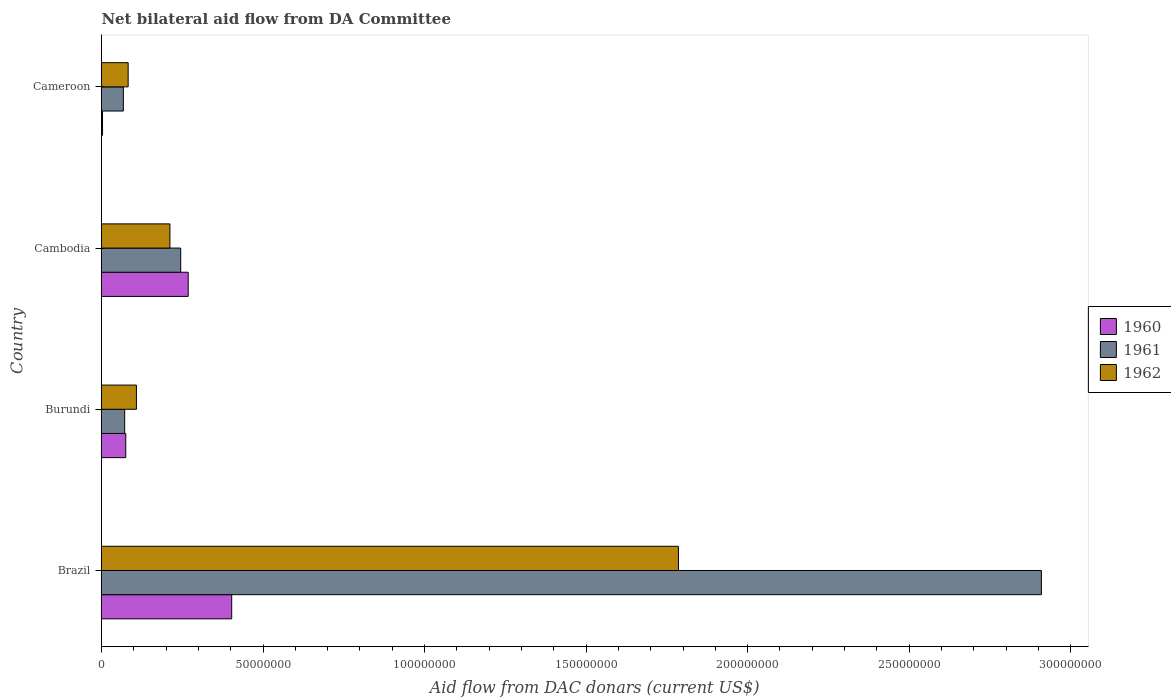Are the number of bars per tick equal to the number of legend labels?
Your response must be concise. Yes. How many bars are there on the 1st tick from the top?
Your answer should be compact. 3. What is the label of the 3rd group of bars from the top?
Your answer should be compact. Burundi. What is the aid flow in in 1960 in Burundi?
Ensure brevity in your answer.  7.51e+06. Across all countries, what is the maximum aid flow in in 1962?
Keep it short and to the point. 1.79e+08. Across all countries, what is the minimum aid flow in in 1962?
Provide a short and direct response. 8.25e+06. In which country was the aid flow in in 1960 minimum?
Provide a short and direct response. Cameroon. What is the total aid flow in in 1962 in the graph?
Provide a succinct answer. 2.19e+08. What is the difference between the aid flow in in 1962 in Burundi and that in Cambodia?
Keep it short and to the point. -1.04e+07. What is the difference between the aid flow in in 1962 in Cameroon and the aid flow in in 1960 in Brazil?
Your answer should be compact. -3.20e+07. What is the average aid flow in in 1962 per country?
Ensure brevity in your answer.  5.47e+07. What is the difference between the aid flow in in 1962 and aid flow in in 1960 in Cambodia?
Offer a very short reply. -5.65e+06. What is the ratio of the aid flow in in 1960 in Burundi to that in Cameroon?
Your response must be concise. 23.47. What is the difference between the highest and the second highest aid flow in in 1961?
Provide a succinct answer. 2.66e+08. What is the difference between the highest and the lowest aid flow in in 1962?
Provide a short and direct response. 1.70e+08. In how many countries, is the aid flow in in 1960 greater than the average aid flow in in 1960 taken over all countries?
Offer a very short reply. 2. What does the 3rd bar from the bottom in Cameroon represents?
Offer a very short reply. 1962. Is it the case that in every country, the sum of the aid flow in in 1961 and aid flow in in 1960 is greater than the aid flow in in 1962?
Make the answer very short. No. How many countries are there in the graph?
Offer a very short reply. 4. What is the difference between two consecutive major ticks on the X-axis?
Ensure brevity in your answer.  5.00e+07. Where does the legend appear in the graph?
Offer a terse response. Center right. What is the title of the graph?
Provide a short and direct response. Net bilateral aid flow from DA Committee. What is the label or title of the X-axis?
Offer a terse response. Aid flow from DAC donars (current US$). What is the label or title of the Y-axis?
Offer a very short reply. Country. What is the Aid flow from DAC donars (current US$) in 1960 in Brazil?
Your answer should be compact. 4.03e+07. What is the Aid flow from DAC donars (current US$) in 1961 in Brazil?
Your response must be concise. 2.91e+08. What is the Aid flow from DAC donars (current US$) in 1962 in Brazil?
Your answer should be compact. 1.79e+08. What is the Aid flow from DAC donars (current US$) of 1960 in Burundi?
Provide a succinct answer. 7.51e+06. What is the Aid flow from DAC donars (current US$) in 1961 in Burundi?
Provide a succinct answer. 7.17e+06. What is the Aid flow from DAC donars (current US$) in 1962 in Burundi?
Keep it short and to the point. 1.08e+07. What is the Aid flow from DAC donars (current US$) in 1960 in Cambodia?
Provide a succinct answer. 2.68e+07. What is the Aid flow from DAC donars (current US$) of 1961 in Cambodia?
Provide a succinct answer. 2.45e+07. What is the Aid flow from DAC donars (current US$) in 1962 in Cambodia?
Give a very brief answer. 2.12e+07. What is the Aid flow from DAC donars (current US$) in 1961 in Cameroon?
Keep it short and to the point. 6.76e+06. What is the Aid flow from DAC donars (current US$) in 1962 in Cameroon?
Make the answer very short. 8.25e+06. Across all countries, what is the maximum Aid flow from DAC donars (current US$) in 1960?
Give a very brief answer. 4.03e+07. Across all countries, what is the maximum Aid flow from DAC donars (current US$) of 1961?
Your answer should be very brief. 2.91e+08. Across all countries, what is the maximum Aid flow from DAC donars (current US$) of 1962?
Give a very brief answer. 1.79e+08. Across all countries, what is the minimum Aid flow from DAC donars (current US$) of 1960?
Your answer should be very brief. 3.20e+05. Across all countries, what is the minimum Aid flow from DAC donars (current US$) in 1961?
Make the answer very short. 6.76e+06. Across all countries, what is the minimum Aid flow from DAC donars (current US$) of 1962?
Your answer should be very brief. 8.25e+06. What is the total Aid flow from DAC donars (current US$) in 1960 in the graph?
Keep it short and to the point. 7.50e+07. What is the total Aid flow from DAC donars (current US$) in 1961 in the graph?
Your response must be concise. 3.29e+08. What is the total Aid flow from DAC donars (current US$) in 1962 in the graph?
Provide a succinct answer. 2.19e+08. What is the difference between the Aid flow from DAC donars (current US$) of 1960 in Brazil and that in Burundi?
Provide a succinct answer. 3.28e+07. What is the difference between the Aid flow from DAC donars (current US$) in 1961 in Brazil and that in Burundi?
Provide a succinct answer. 2.84e+08. What is the difference between the Aid flow from DAC donars (current US$) of 1962 in Brazil and that in Burundi?
Your response must be concise. 1.68e+08. What is the difference between the Aid flow from DAC donars (current US$) of 1960 in Brazil and that in Cambodia?
Give a very brief answer. 1.35e+07. What is the difference between the Aid flow from DAC donars (current US$) of 1961 in Brazil and that in Cambodia?
Make the answer very short. 2.66e+08. What is the difference between the Aid flow from DAC donars (current US$) in 1962 in Brazil and that in Cambodia?
Make the answer very short. 1.57e+08. What is the difference between the Aid flow from DAC donars (current US$) of 1960 in Brazil and that in Cameroon?
Your answer should be compact. 4.00e+07. What is the difference between the Aid flow from DAC donars (current US$) of 1961 in Brazil and that in Cameroon?
Your answer should be compact. 2.84e+08. What is the difference between the Aid flow from DAC donars (current US$) of 1962 in Brazil and that in Cameroon?
Give a very brief answer. 1.70e+08. What is the difference between the Aid flow from DAC donars (current US$) in 1960 in Burundi and that in Cambodia?
Your answer should be compact. -1.93e+07. What is the difference between the Aid flow from DAC donars (current US$) of 1961 in Burundi and that in Cambodia?
Provide a short and direct response. -1.74e+07. What is the difference between the Aid flow from DAC donars (current US$) in 1962 in Burundi and that in Cambodia?
Give a very brief answer. -1.04e+07. What is the difference between the Aid flow from DAC donars (current US$) of 1960 in Burundi and that in Cameroon?
Make the answer very short. 7.19e+06. What is the difference between the Aid flow from DAC donars (current US$) of 1962 in Burundi and that in Cameroon?
Provide a succinct answer. 2.56e+06. What is the difference between the Aid flow from DAC donars (current US$) of 1960 in Cambodia and that in Cameroon?
Provide a short and direct response. 2.65e+07. What is the difference between the Aid flow from DAC donars (current US$) in 1961 in Cambodia and that in Cameroon?
Your response must be concise. 1.78e+07. What is the difference between the Aid flow from DAC donars (current US$) in 1962 in Cambodia and that in Cameroon?
Offer a terse response. 1.29e+07. What is the difference between the Aid flow from DAC donars (current US$) of 1960 in Brazil and the Aid flow from DAC donars (current US$) of 1961 in Burundi?
Ensure brevity in your answer.  3.31e+07. What is the difference between the Aid flow from DAC donars (current US$) of 1960 in Brazil and the Aid flow from DAC donars (current US$) of 1962 in Burundi?
Your answer should be very brief. 2.95e+07. What is the difference between the Aid flow from DAC donars (current US$) of 1961 in Brazil and the Aid flow from DAC donars (current US$) of 1962 in Burundi?
Keep it short and to the point. 2.80e+08. What is the difference between the Aid flow from DAC donars (current US$) of 1960 in Brazil and the Aid flow from DAC donars (current US$) of 1961 in Cambodia?
Your response must be concise. 1.58e+07. What is the difference between the Aid flow from DAC donars (current US$) in 1960 in Brazil and the Aid flow from DAC donars (current US$) in 1962 in Cambodia?
Your response must be concise. 1.91e+07. What is the difference between the Aid flow from DAC donars (current US$) in 1961 in Brazil and the Aid flow from DAC donars (current US$) in 1962 in Cambodia?
Offer a very short reply. 2.70e+08. What is the difference between the Aid flow from DAC donars (current US$) of 1960 in Brazil and the Aid flow from DAC donars (current US$) of 1961 in Cameroon?
Make the answer very short. 3.35e+07. What is the difference between the Aid flow from DAC donars (current US$) of 1960 in Brazil and the Aid flow from DAC donars (current US$) of 1962 in Cameroon?
Offer a very short reply. 3.20e+07. What is the difference between the Aid flow from DAC donars (current US$) in 1961 in Brazil and the Aid flow from DAC donars (current US$) in 1962 in Cameroon?
Give a very brief answer. 2.83e+08. What is the difference between the Aid flow from DAC donars (current US$) of 1960 in Burundi and the Aid flow from DAC donars (current US$) of 1961 in Cambodia?
Make the answer very short. -1.70e+07. What is the difference between the Aid flow from DAC donars (current US$) of 1960 in Burundi and the Aid flow from DAC donars (current US$) of 1962 in Cambodia?
Your response must be concise. -1.37e+07. What is the difference between the Aid flow from DAC donars (current US$) in 1961 in Burundi and the Aid flow from DAC donars (current US$) in 1962 in Cambodia?
Make the answer very short. -1.40e+07. What is the difference between the Aid flow from DAC donars (current US$) in 1960 in Burundi and the Aid flow from DAC donars (current US$) in 1961 in Cameroon?
Offer a terse response. 7.50e+05. What is the difference between the Aid flow from DAC donars (current US$) in 1960 in Burundi and the Aid flow from DAC donars (current US$) in 1962 in Cameroon?
Your answer should be compact. -7.40e+05. What is the difference between the Aid flow from DAC donars (current US$) in 1961 in Burundi and the Aid flow from DAC donars (current US$) in 1962 in Cameroon?
Make the answer very short. -1.08e+06. What is the difference between the Aid flow from DAC donars (current US$) of 1960 in Cambodia and the Aid flow from DAC donars (current US$) of 1961 in Cameroon?
Your answer should be compact. 2.01e+07. What is the difference between the Aid flow from DAC donars (current US$) in 1960 in Cambodia and the Aid flow from DAC donars (current US$) in 1962 in Cameroon?
Offer a terse response. 1.86e+07. What is the difference between the Aid flow from DAC donars (current US$) in 1961 in Cambodia and the Aid flow from DAC donars (current US$) in 1962 in Cameroon?
Provide a short and direct response. 1.63e+07. What is the average Aid flow from DAC donars (current US$) of 1960 per country?
Keep it short and to the point. 1.87e+07. What is the average Aid flow from DAC donars (current US$) of 1961 per country?
Your answer should be very brief. 8.23e+07. What is the average Aid flow from DAC donars (current US$) in 1962 per country?
Your response must be concise. 5.47e+07. What is the difference between the Aid flow from DAC donars (current US$) of 1960 and Aid flow from DAC donars (current US$) of 1961 in Brazil?
Offer a terse response. -2.51e+08. What is the difference between the Aid flow from DAC donars (current US$) of 1960 and Aid flow from DAC donars (current US$) of 1962 in Brazil?
Your response must be concise. -1.38e+08. What is the difference between the Aid flow from DAC donars (current US$) in 1961 and Aid flow from DAC donars (current US$) in 1962 in Brazil?
Provide a short and direct response. 1.12e+08. What is the difference between the Aid flow from DAC donars (current US$) of 1960 and Aid flow from DAC donars (current US$) of 1962 in Burundi?
Your response must be concise. -3.30e+06. What is the difference between the Aid flow from DAC donars (current US$) in 1961 and Aid flow from DAC donars (current US$) in 1962 in Burundi?
Your answer should be compact. -3.64e+06. What is the difference between the Aid flow from DAC donars (current US$) in 1960 and Aid flow from DAC donars (current US$) in 1961 in Cambodia?
Ensure brevity in your answer.  2.31e+06. What is the difference between the Aid flow from DAC donars (current US$) in 1960 and Aid flow from DAC donars (current US$) in 1962 in Cambodia?
Provide a succinct answer. 5.65e+06. What is the difference between the Aid flow from DAC donars (current US$) in 1961 and Aid flow from DAC donars (current US$) in 1962 in Cambodia?
Give a very brief answer. 3.34e+06. What is the difference between the Aid flow from DAC donars (current US$) of 1960 and Aid flow from DAC donars (current US$) of 1961 in Cameroon?
Give a very brief answer. -6.44e+06. What is the difference between the Aid flow from DAC donars (current US$) in 1960 and Aid flow from DAC donars (current US$) in 1962 in Cameroon?
Offer a terse response. -7.93e+06. What is the difference between the Aid flow from DAC donars (current US$) in 1961 and Aid flow from DAC donars (current US$) in 1962 in Cameroon?
Offer a very short reply. -1.49e+06. What is the ratio of the Aid flow from DAC donars (current US$) in 1960 in Brazil to that in Burundi?
Your answer should be very brief. 5.37. What is the ratio of the Aid flow from DAC donars (current US$) in 1961 in Brazil to that in Burundi?
Your answer should be compact. 40.57. What is the ratio of the Aid flow from DAC donars (current US$) in 1962 in Brazil to that in Burundi?
Your response must be concise. 16.52. What is the ratio of the Aid flow from DAC donars (current US$) in 1960 in Brazil to that in Cambodia?
Provide a succinct answer. 1.5. What is the ratio of the Aid flow from DAC donars (current US$) of 1961 in Brazil to that in Cambodia?
Offer a very short reply. 11.86. What is the ratio of the Aid flow from DAC donars (current US$) of 1962 in Brazil to that in Cambodia?
Offer a very short reply. 8.43. What is the ratio of the Aid flow from DAC donars (current US$) of 1960 in Brazil to that in Cameroon?
Give a very brief answer. 125.94. What is the ratio of the Aid flow from DAC donars (current US$) in 1961 in Brazil to that in Cameroon?
Offer a very short reply. 43.04. What is the ratio of the Aid flow from DAC donars (current US$) of 1962 in Brazil to that in Cameroon?
Provide a succinct answer. 21.65. What is the ratio of the Aid flow from DAC donars (current US$) of 1960 in Burundi to that in Cambodia?
Give a very brief answer. 0.28. What is the ratio of the Aid flow from DAC donars (current US$) in 1961 in Burundi to that in Cambodia?
Make the answer very short. 0.29. What is the ratio of the Aid flow from DAC donars (current US$) in 1962 in Burundi to that in Cambodia?
Offer a terse response. 0.51. What is the ratio of the Aid flow from DAC donars (current US$) in 1960 in Burundi to that in Cameroon?
Offer a terse response. 23.47. What is the ratio of the Aid flow from DAC donars (current US$) in 1961 in Burundi to that in Cameroon?
Make the answer very short. 1.06. What is the ratio of the Aid flow from DAC donars (current US$) in 1962 in Burundi to that in Cameroon?
Offer a terse response. 1.31. What is the ratio of the Aid flow from DAC donars (current US$) of 1960 in Cambodia to that in Cameroon?
Your answer should be very brief. 83.84. What is the ratio of the Aid flow from DAC donars (current US$) of 1961 in Cambodia to that in Cameroon?
Keep it short and to the point. 3.63. What is the ratio of the Aid flow from DAC donars (current US$) of 1962 in Cambodia to that in Cameroon?
Offer a very short reply. 2.57. What is the difference between the highest and the second highest Aid flow from DAC donars (current US$) of 1960?
Your response must be concise. 1.35e+07. What is the difference between the highest and the second highest Aid flow from DAC donars (current US$) in 1961?
Keep it short and to the point. 2.66e+08. What is the difference between the highest and the second highest Aid flow from DAC donars (current US$) in 1962?
Offer a terse response. 1.57e+08. What is the difference between the highest and the lowest Aid flow from DAC donars (current US$) of 1960?
Keep it short and to the point. 4.00e+07. What is the difference between the highest and the lowest Aid flow from DAC donars (current US$) of 1961?
Offer a terse response. 2.84e+08. What is the difference between the highest and the lowest Aid flow from DAC donars (current US$) in 1962?
Provide a short and direct response. 1.70e+08. 